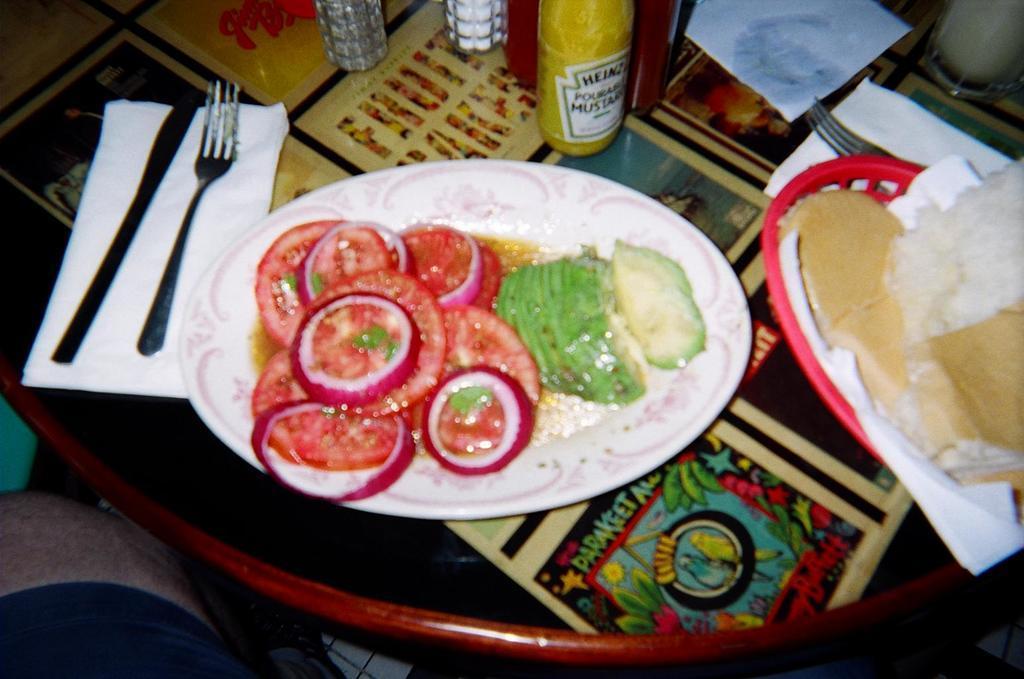How would you summarize this image in a sentence or two? In the picture I can see plate, spoon, tissue, bottles, food item and some other objects. 